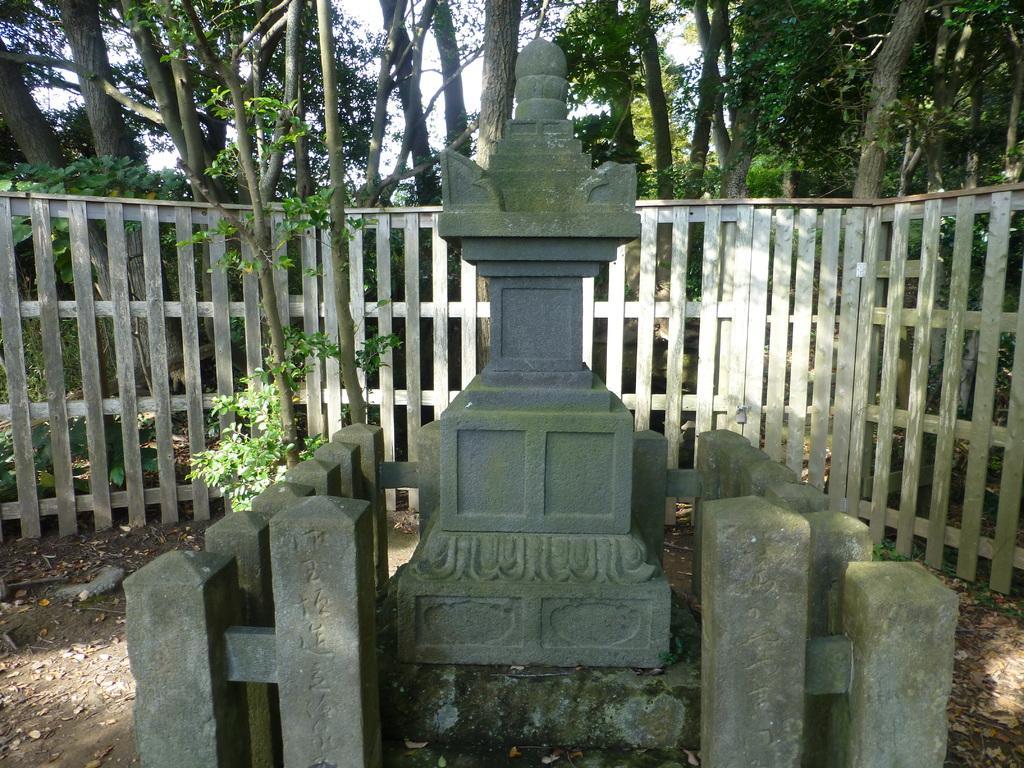In one or two sentences, can you explain what this image depicts? This image consists of some statue in the middle. There are trees at the top. There are plants in the middle. 